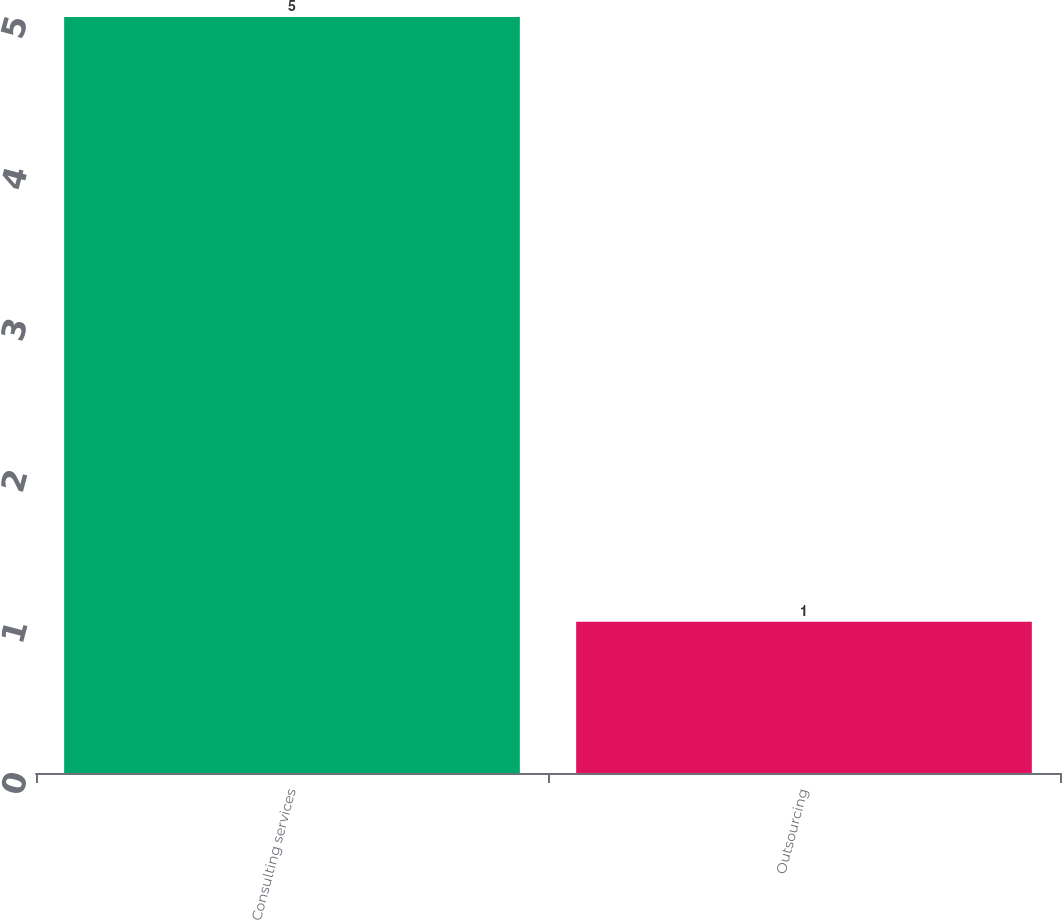Convert chart. <chart><loc_0><loc_0><loc_500><loc_500><bar_chart><fcel>Consulting services<fcel>Outsourcing<nl><fcel>5<fcel>1<nl></chart> 